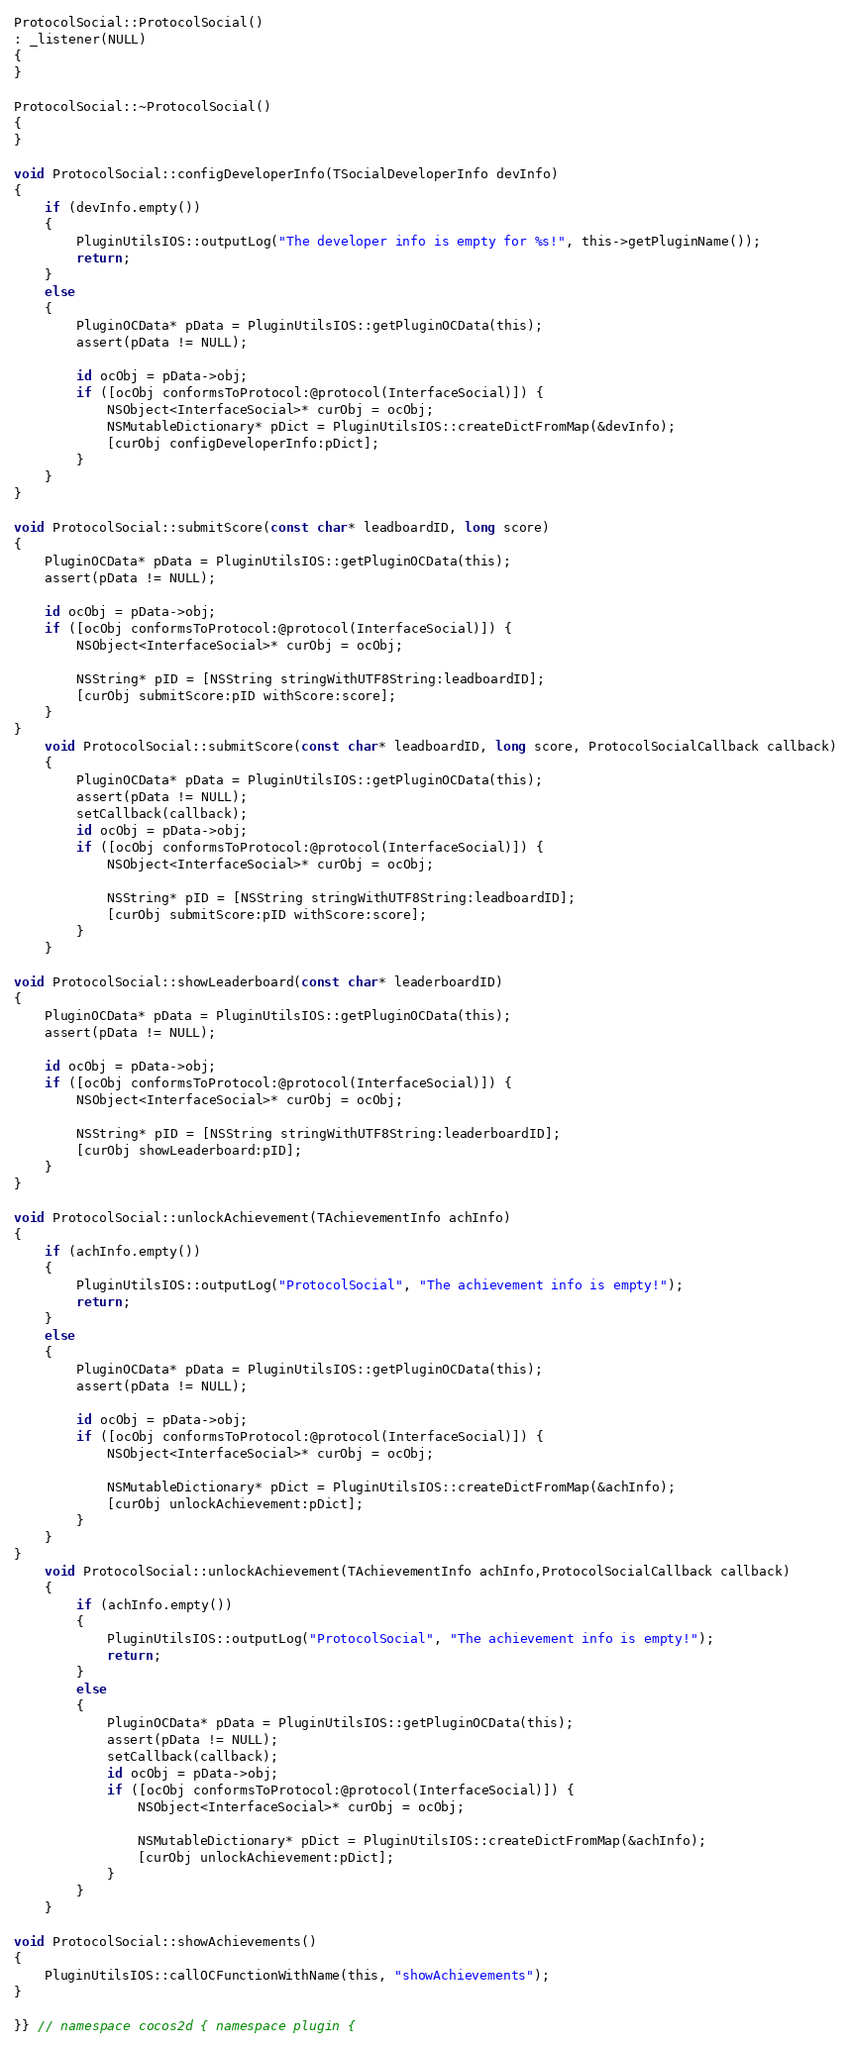<code> <loc_0><loc_0><loc_500><loc_500><_ObjectiveC_>
ProtocolSocial::ProtocolSocial()
: _listener(NULL)
{
}

ProtocolSocial::~ProtocolSocial()
{
}

void ProtocolSocial::configDeveloperInfo(TSocialDeveloperInfo devInfo)
{
    if (devInfo.empty())
    {
        PluginUtilsIOS::outputLog("The developer info is empty for %s!", this->getPluginName());
        return;
    }
    else
    {
        PluginOCData* pData = PluginUtilsIOS::getPluginOCData(this);
        assert(pData != NULL);
        
        id ocObj = pData->obj;
        if ([ocObj conformsToProtocol:@protocol(InterfaceSocial)]) {
            NSObject<InterfaceSocial>* curObj = ocObj;
            NSMutableDictionary* pDict = PluginUtilsIOS::createDictFromMap(&devInfo);
            [curObj configDeveloperInfo:pDict];
        }
    }
}
    
void ProtocolSocial::submitScore(const char* leadboardID, long score)
{
    PluginOCData* pData = PluginUtilsIOS::getPluginOCData(this);
    assert(pData != NULL);

    id ocObj = pData->obj;
    if ([ocObj conformsToProtocol:@protocol(InterfaceSocial)]) {
        NSObject<InterfaceSocial>* curObj = ocObj;
        
        NSString* pID = [NSString stringWithUTF8String:leadboardID];
        [curObj submitScore:pID withScore:score];
    }
}
    void ProtocolSocial::submitScore(const char* leadboardID, long score, ProtocolSocialCallback callback)
    {
        PluginOCData* pData = PluginUtilsIOS::getPluginOCData(this);
        assert(pData != NULL);
        setCallback(callback);
        id ocObj = pData->obj;
        if ([ocObj conformsToProtocol:@protocol(InterfaceSocial)]) {
            NSObject<InterfaceSocial>* curObj = ocObj;
            
            NSString* pID = [NSString stringWithUTF8String:leadboardID];
            [curObj submitScore:pID withScore:score];
        }
    }

void ProtocolSocial::showLeaderboard(const char* leaderboardID)
{
    PluginOCData* pData = PluginUtilsIOS::getPluginOCData(this);
    assert(pData != NULL);
    
    id ocObj = pData->obj;
    if ([ocObj conformsToProtocol:@protocol(InterfaceSocial)]) {
        NSObject<InterfaceSocial>* curObj = ocObj;
        
        NSString* pID = [NSString stringWithUTF8String:leaderboardID];
        [curObj showLeaderboard:pID];
    }
}

void ProtocolSocial::unlockAchievement(TAchievementInfo achInfo)
{
    if (achInfo.empty())
    {
        PluginUtilsIOS::outputLog("ProtocolSocial", "The achievement info is empty!");
        return;
    }
    else
    {
        PluginOCData* pData = PluginUtilsIOS::getPluginOCData(this);
        assert(pData != NULL);
        
        id ocObj = pData->obj;
        if ([ocObj conformsToProtocol:@protocol(InterfaceSocial)]) {
            NSObject<InterfaceSocial>* curObj = ocObj;
            
            NSMutableDictionary* pDict = PluginUtilsIOS::createDictFromMap(&achInfo);
            [curObj unlockAchievement:pDict];
        }
    }
}
    void ProtocolSocial::unlockAchievement(TAchievementInfo achInfo,ProtocolSocialCallback callback)
    {
        if (achInfo.empty())
        {
            PluginUtilsIOS::outputLog("ProtocolSocial", "The achievement info is empty!");
            return;
        }
        else
        {
            PluginOCData* pData = PluginUtilsIOS::getPluginOCData(this);
            assert(pData != NULL);
            setCallback(callback);
            id ocObj = pData->obj;
            if ([ocObj conformsToProtocol:@protocol(InterfaceSocial)]) {
                NSObject<InterfaceSocial>* curObj = ocObj;
                
                NSMutableDictionary* pDict = PluginUtilsIOS::createDictFromMap(&achInfo);
                [curObj unlockAchievement:pDict];
            }
        }
    }

void ProtocolSocial::showAchievements()
{
    PluginUtilsIOS::callOCFunctionWithName(this, "showAchievements");
}

}} // namespace cocos2d { namespace plugin {
</code> 